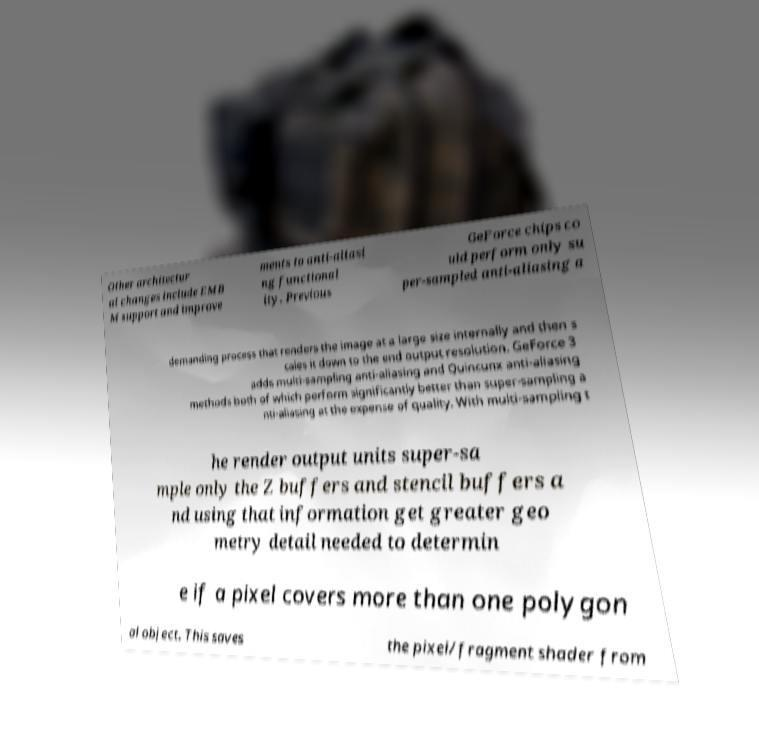Please read and relay the text visible in this image. What does it say? Other architectur al changes include EMB M support and improve ments to anti-aliasi ng functional ity. Previous GeForce chips co uld perform only su per-sampled anti-aliasing a demanding process that renders the image at a large size internally and then s cales it down to the end output resolution. GeForce 3 adds multi-sampling anti-aliasing and Quincunx anti-aliasing methods both of which perform significantly better than super-sampling a nti-aliasing at the expense of quality. With multi-sampling t he render output units super-sa mple only the Z buffers and stencil buffers a nd using that information get greater geo metry detail needed to determin e if a pixel covers more than one polygon al object. This saves the pixel/fragment shader from 